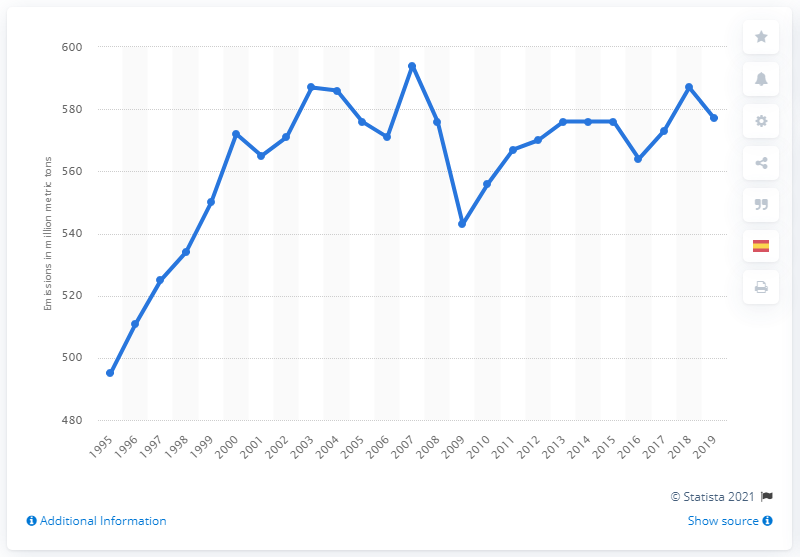Point out several critical features in this image. In 2019, Canada's carbon dioxide emissions from fossil fuel and cement production were approximately 577 metric tons. In 1995, Canada emitted approximately 495 metric tons of carbon dioxide. 